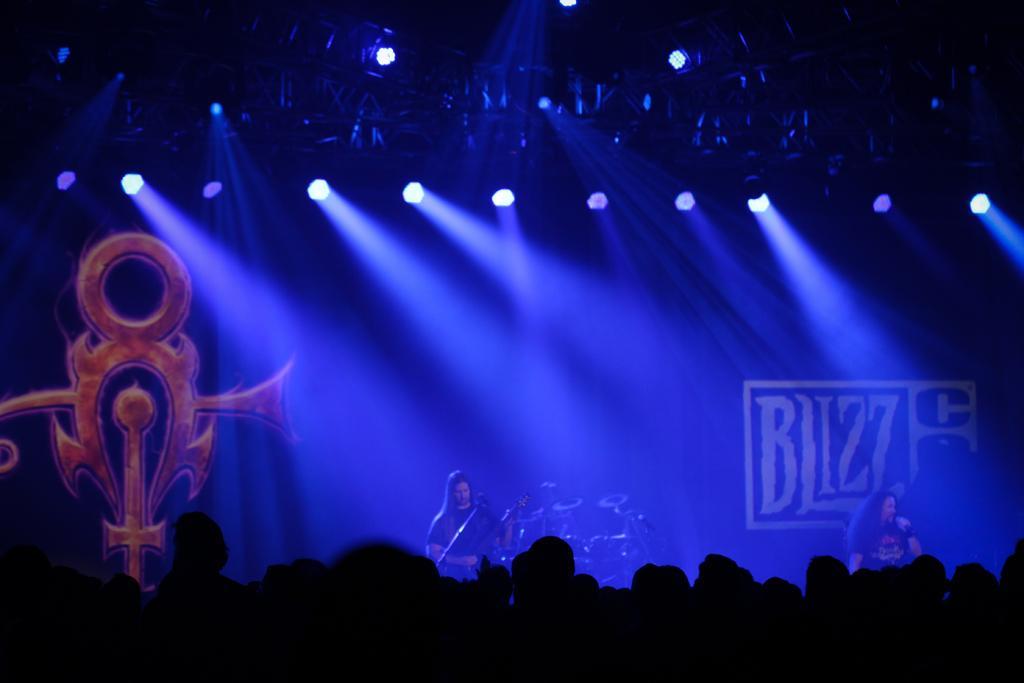In one or two sentences, can you explain what this image depicts? In this image we can see two persons, microphones and other objects. In the background of the image there is a banner. At the top of the image there are lights and other objects. At the bottom of the image it looks like some persons. 